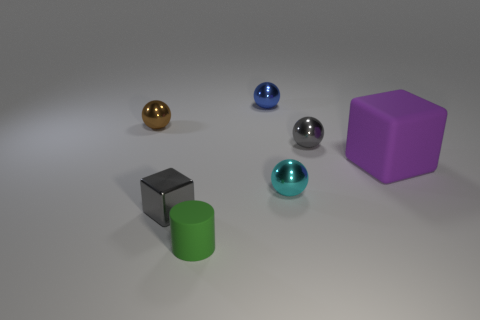What materials do the objects in the image seem to be made of? The objects in the image appear to have a smooth, reflective surface, suggesting they might be made of materials like plastic or polished metal, useful for giving a simple yet realistic look that's often used in 3D modeling and rendering. 